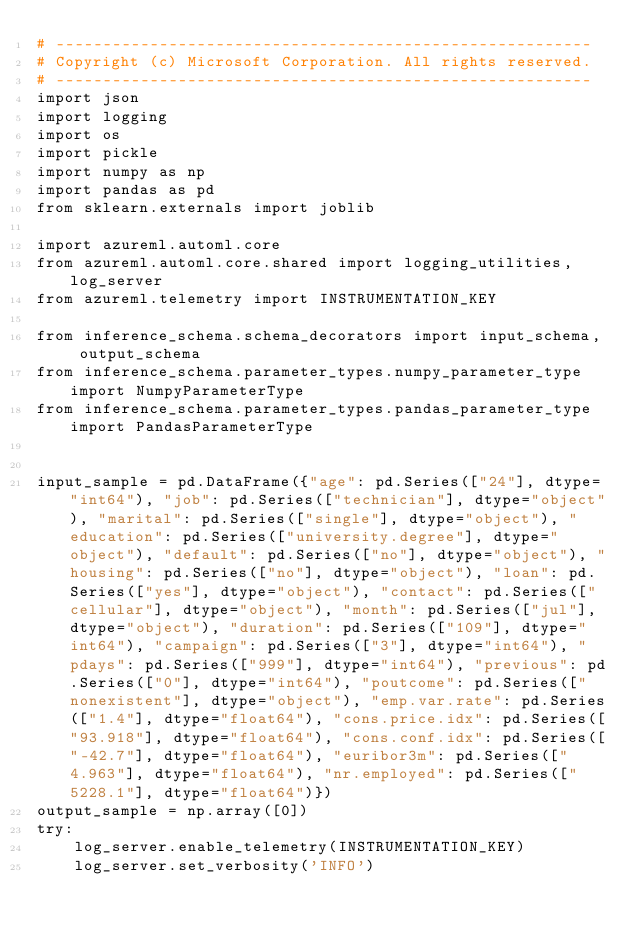Convert code to text. <code><loc_0><loc_0><loc_500><loc_500><_Python_># ---------------------------------------------------------
# Copyright (c) Microsoft Corporation. All rights reserved.
# ---------------------------------------------------------
import json
import logging
import os
import pickle
import numpy as np
import pandas as pd
from sklearn.externals import joblib

import azureml.automl.core
from azureml.automl.core.shared import logging_utilities, log_server
from azureml.telemetry import INSTRUMENTATION_KEY

from inference_schema.schema_decorators import input_schema, output_schema
from inference_schema.parameter_types.numpy_parameter_type import NumpyParameterType
from inference_schema.parameter_types.pandas_parameter_type import PandasParameterType


input_sample = pd.DataFrame({"age": pd.Series(["24"], dtype="int64"), "job": pd.Series(["technician"], dtype="object"), "marital": pd.Series(["single"], dtype="object"), "education": pd.Series(["university.degree"], dtype="object"), "default": pd.Series(["no"], dtype="object"), "housing": pd.Series(["no"], dtype="object"), "loan": pd.Series(["yes"], dtype="object"), "contact": pd.Series(["cellular"], dtype="object"), "month": pd.Series(["jul"], dtype="object"), "duration": pd.Series(["109"], dtype="int64"), "campaign": pd.Series(["3"], dtype="int64"), "pdays": pd.Series(["999"], dtype="int64"), "previous": pd.Series(["0"], dtype="int64"), "poutcome": pd.Series(["nonexistent"], dtype="object"), "emp.var.rate": pd.Series(["1.4"], dtype="float64"), "cons.price.idx": pd.Series(["93.918"], dtype="float64"), "cons.conf.idx": pd.Series(["-42.7"], dtype="float64"), "euribor3m": pd.Series(["4.963"], dtype="float64"), "nr.employed": pd.Series(["5228.1"], dtype="float64")})
output_sample = np.array([0])
try:
    log_server.enable_telemetry(INSTRUMENTATION_KEY)
    log_server.set_verbosity('INFO')</code> 